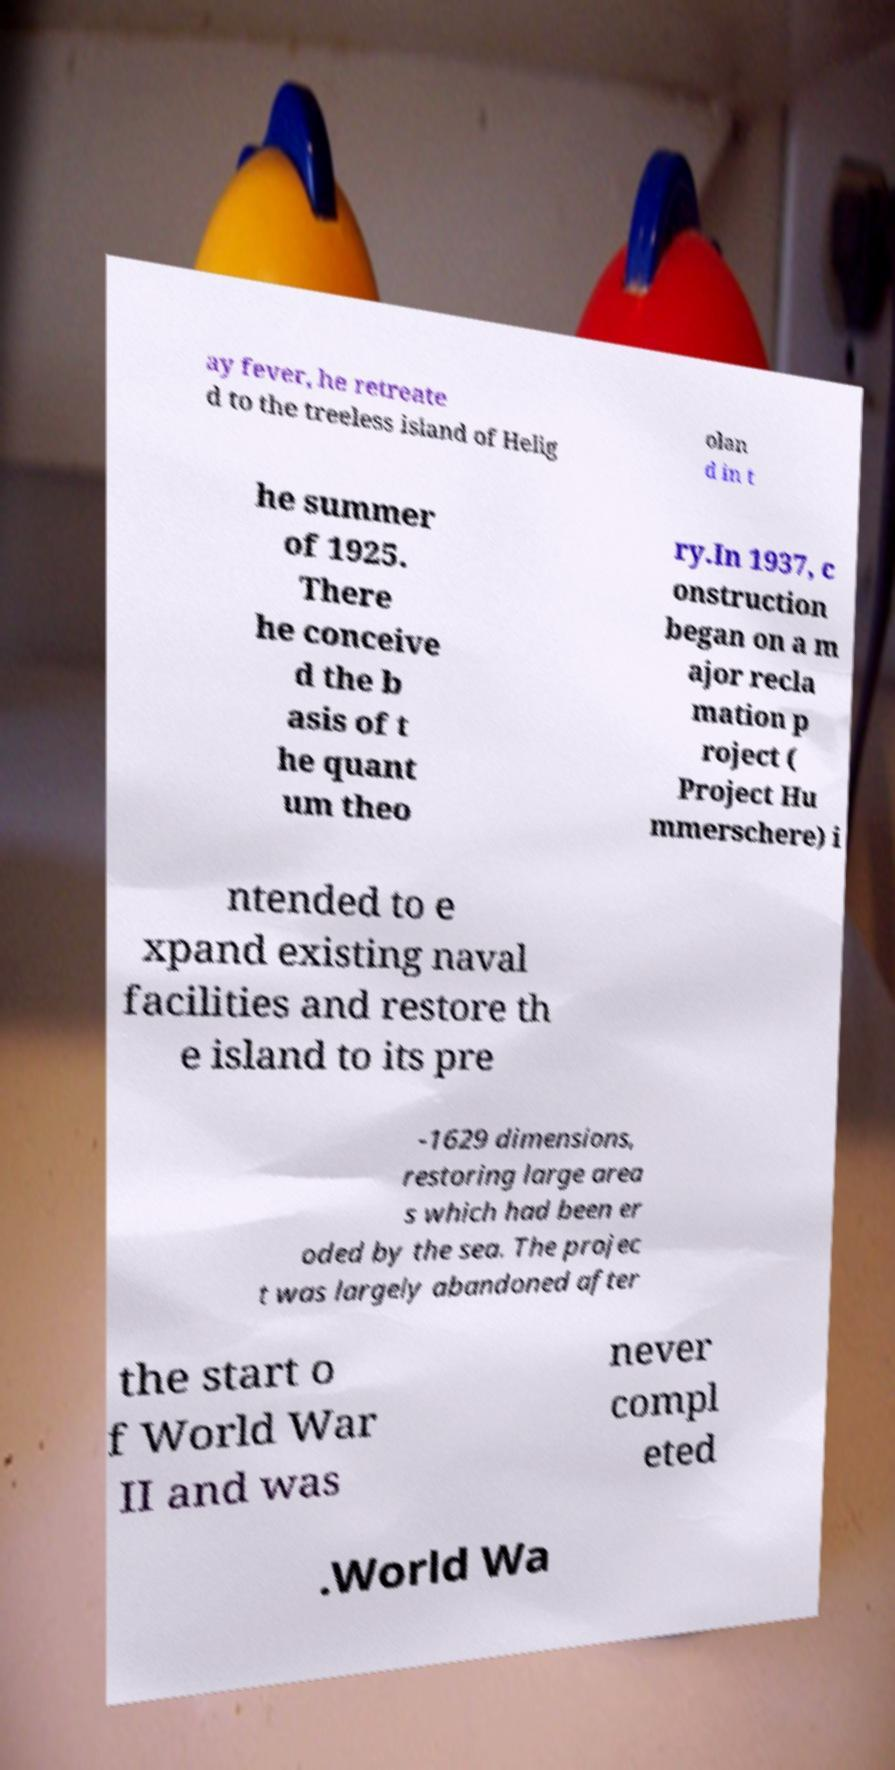Please identify and transcribe the text found in this image. ay fever, he retreate d to the treeless island of Helig olan d in t he summer of 1925. There he conceive d the b asis of t he quant um theo ry.In 1937, c onstruction began on a m ajor recla mation p roject ( Project Hu mmerschere) i ntended to e xpand existing naval facilities and restore th e island to its pre -1629 dimensions, restoring large area s which had been er oded by the sea. The projec t was largely abandoned after the start o f World War II and was never compl eted .World Wa 